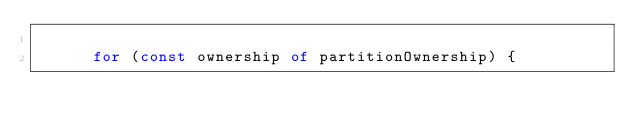<code> <loc_0><loc_0><loc_500><loc_500><_TypeScript_>
      for (const ownership of partitionOwnership) {</code> 